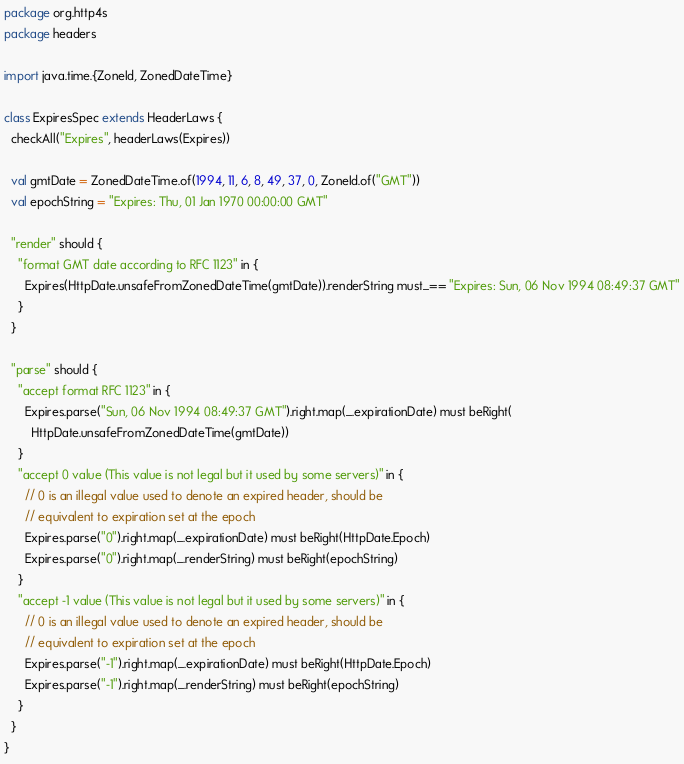<code> <loc_0><loc_0><loc_500><loc_500><_Scala_>package org.http4s
package headers

import java.time.{ZoneId, ZonedDateTime}

class ExpiresSpec extends HeaderLaws {
  checkAll("Expires", headerLaws(Expires))

  val gmtDate = ZonedDateTime.of(1994, 11, 6, 8, 49, 37, 0, ZoneId.of("GMT"))
  val epochString = "Expires: Thu, 01 Jan 1970 00:00:00 GMT"

  "render" should {
    "format GMT date according to RFC 1123" in {
      Expires(HttpDate.unsafeFromZonedDateTime(gmtDate)).renderString must_== "Expires: Sun, 06 Nov 1994 08:49:37 GMT"
    }
  }

  "parse" should {
    "accept format RFC 1123" in {
      Expires.parse("Sun, 06 Nov 1994 08:49:37 GMT").right.map(_.expirationDate) must beRight(
        HttpDate.unsafeFromZonedDateTime(gmtDate))
    }
    "accept 0 value (This value is not legal but it used by some servers)" in {
      // 0 is an illegal value used to denote an expired header, should be
      // equivalent to expiration set at the epoch
      Expires.parse("0").right.map(_.expirationDate) must beRight(HttpDate.Epoch)
      Expires.parse("0").right.map(_.renderString) must beRight(epochString)
    }
    "accept -1 value (This value is not legal but it used by some servers)" in {
      // 0 is an illegal value used to denote an expired header, should be
      // equivalent to expiration set at the epoch
      Expires.parse("-1").right.map(_.expirationDate) must beRight(HttpDate.Epoch)
      Expires.parse("-1").right.map(_.renderString) must beRight(epochString)
    }
  }
}
</code> 